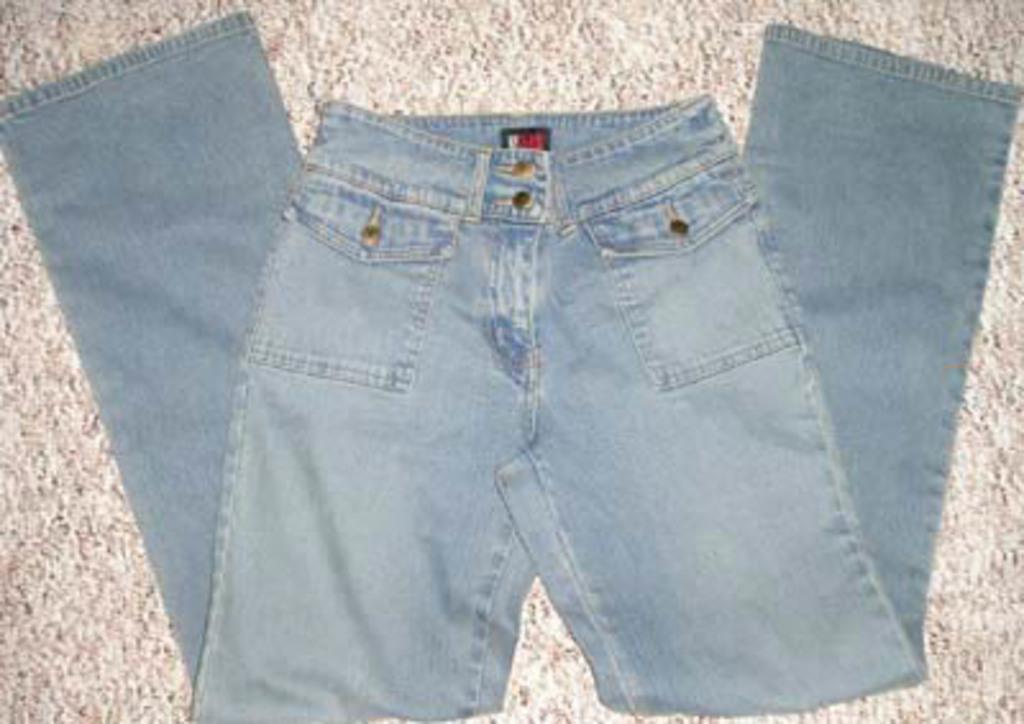Can you describe this image briefly? In this image in the center there is a jeans pant, and in the background it looks like a floor. 